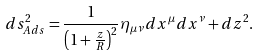<formula> <loc_0><loc_0><loc_500><loc_500>d s _ { A d s } ^ { 2 } = \frac { 1 } { \left ( 1 + \frac { z } { R } \right ) ^ { 2 } } \eta _ { \mu \nu } d x ^ { \mu } d x ^ { \nu } + d z ^ { 2 } .</formula> 